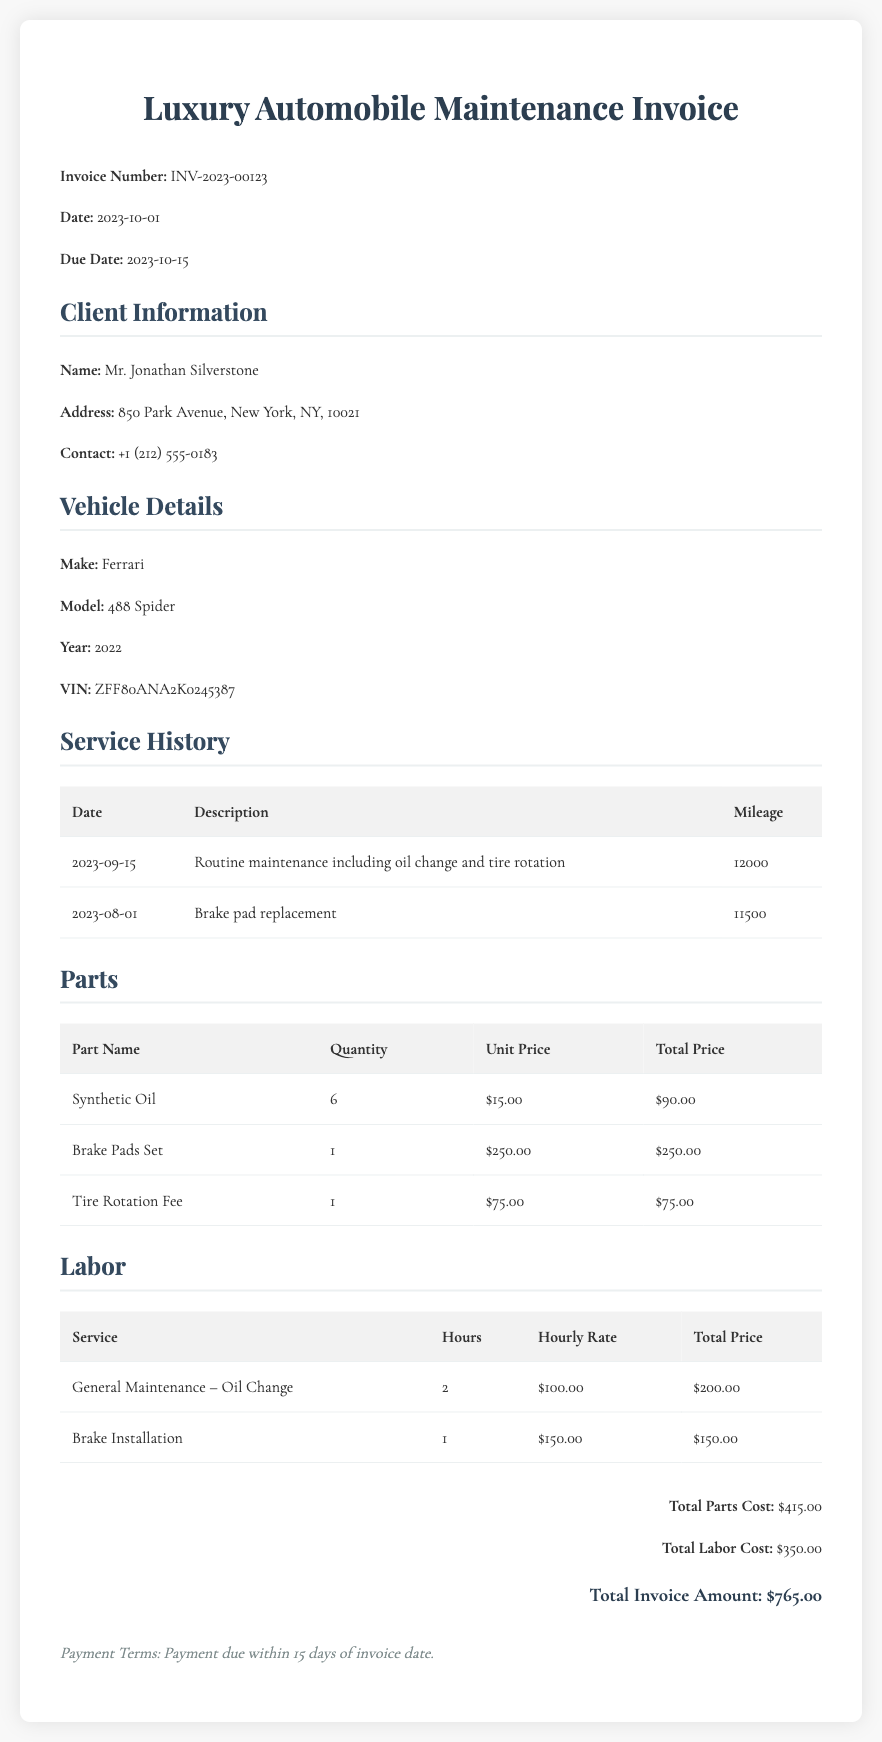what is the invoice number? The invoice number is clearly mentioned in the document, which is INV-2023-00123.
Answer: INV-2023-00123 who is the client? The document specifies the client as Mr. Jonathan Silverstone.
Answer: Mr. Jonathan Silverstone what is the total parts cost? The total parts cost is detailed in the summary section, which totals $415.00.
Answer: $415.00 how many hours were billed for General Maintenance? The labor section lists 2 hours for General Maintenance – Oil Change.
Answer: 2 what is the due date for the payment? The due date for the payment is indicated as 2023-10-15.
Answer: 2023-10-15 what service was performed on 2023-09-15? The service history indicates that routine maintenance including oil change and tire rotation was performed on this date.
Answer: Routine maintenance including oil change and tire rotation what is the total invoice amount? The total invoice amount is the final calculated figure in the summary section, which is $765.00.
Answer: $765.00 how many brake pads sets were included in the parts? The parts table shows that 1 Brake Pads Set was included.
Answer: 1 what is the penalty for late payment? The payment terms specify that payment is due within 15 days of the invoice date, but do not mention a penalty for late payment.
Answer: Not specified 